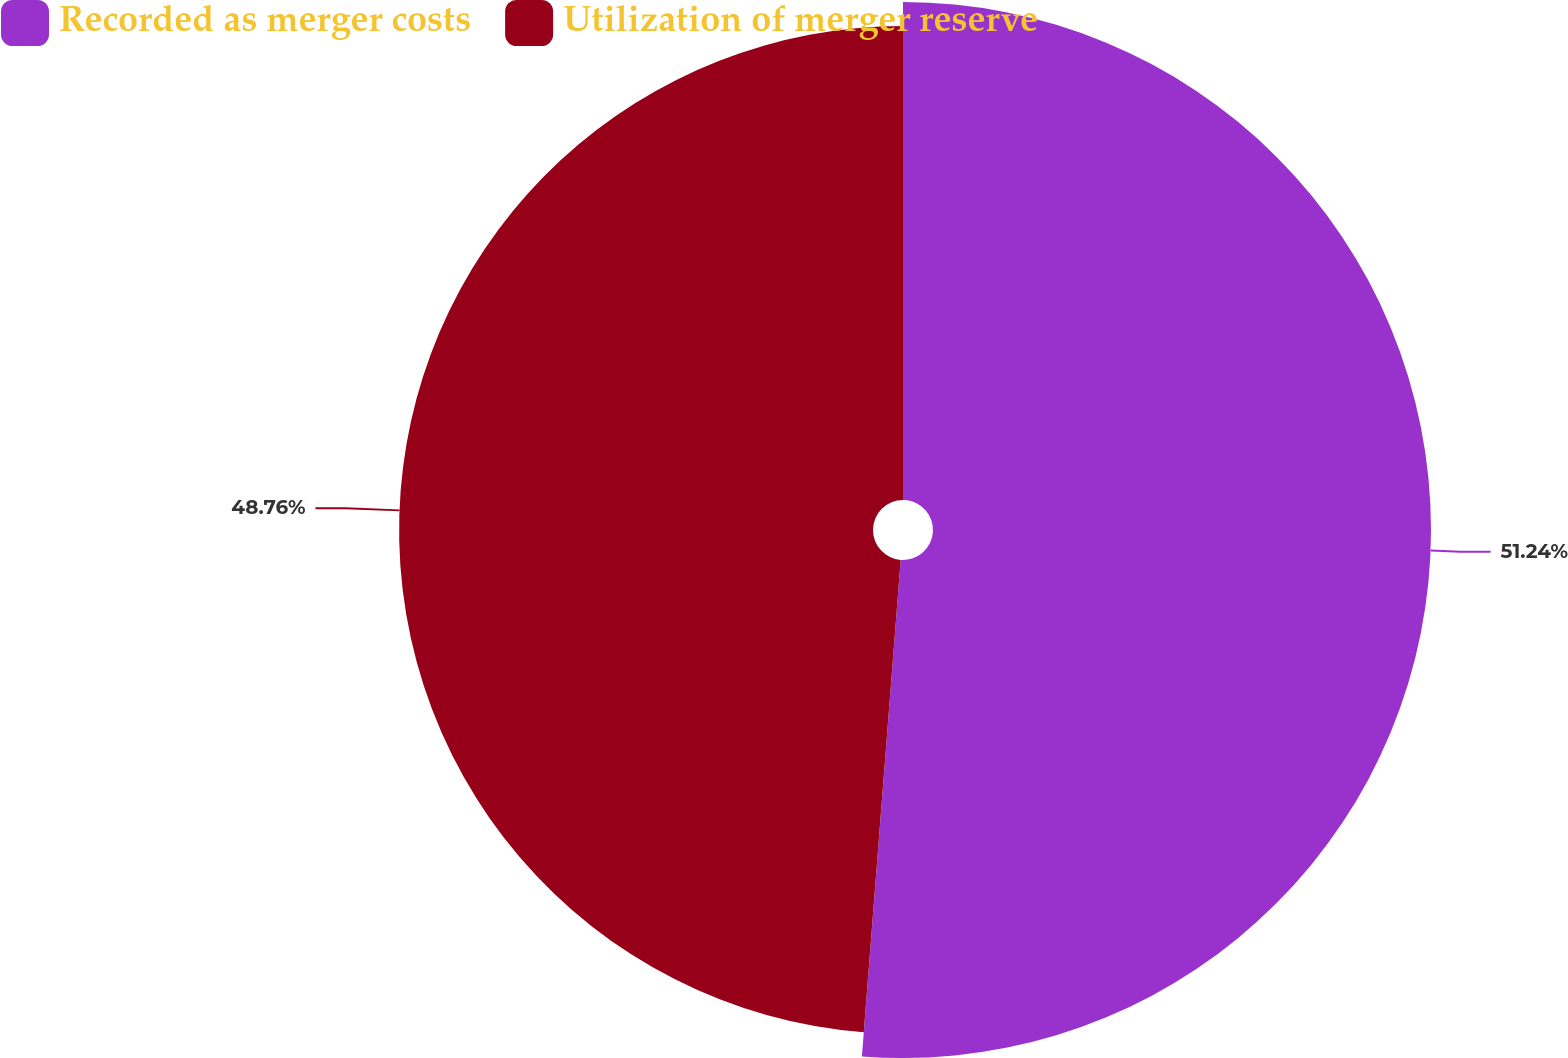Convert chart to OTSL. <chart><loc_0><loc_0><loc_500><loc_500><pie_chart><fcel>Recorded as merger costs<fcel>Utilization of merger reserve<nl><fcel>51.24%<fcel>48.76%<nl></chart> 